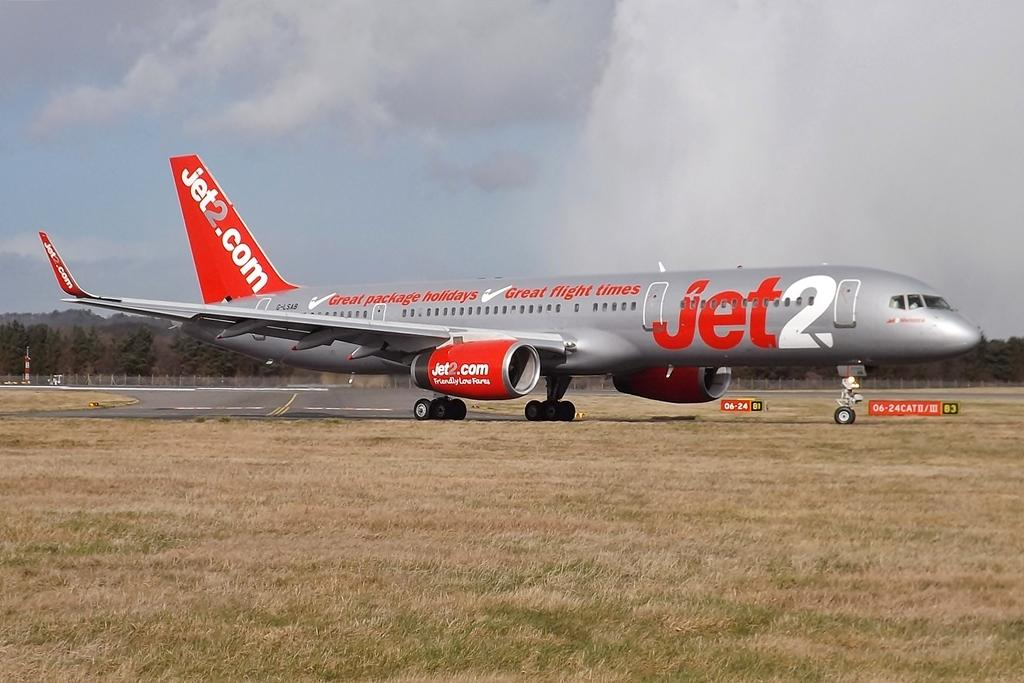<image>
Give a short and clear explanation of the subsequent image. Jet2.com is on a silver plane on a runway. 